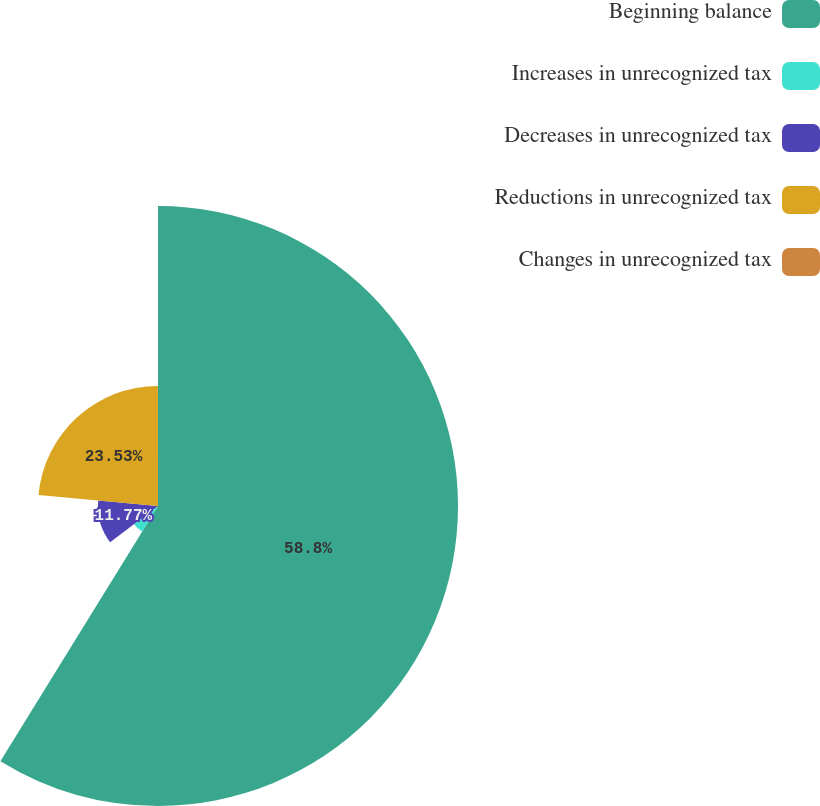<chart> <loc_0><loc_0><loc_500><loc_500><pie_chart><fcel>Beginning balance<fcel>Increases in unrecognized tax<fcel>Decreases in unrecognized tax<fcel>Reductions in unrecognized tax<fcel>Changes in unrecognized tax<nl><fcel>58.81%<fcel>5.89%<fcel>11.77%<fcel>23.53%<fcel>0.01%<nl></chart> 